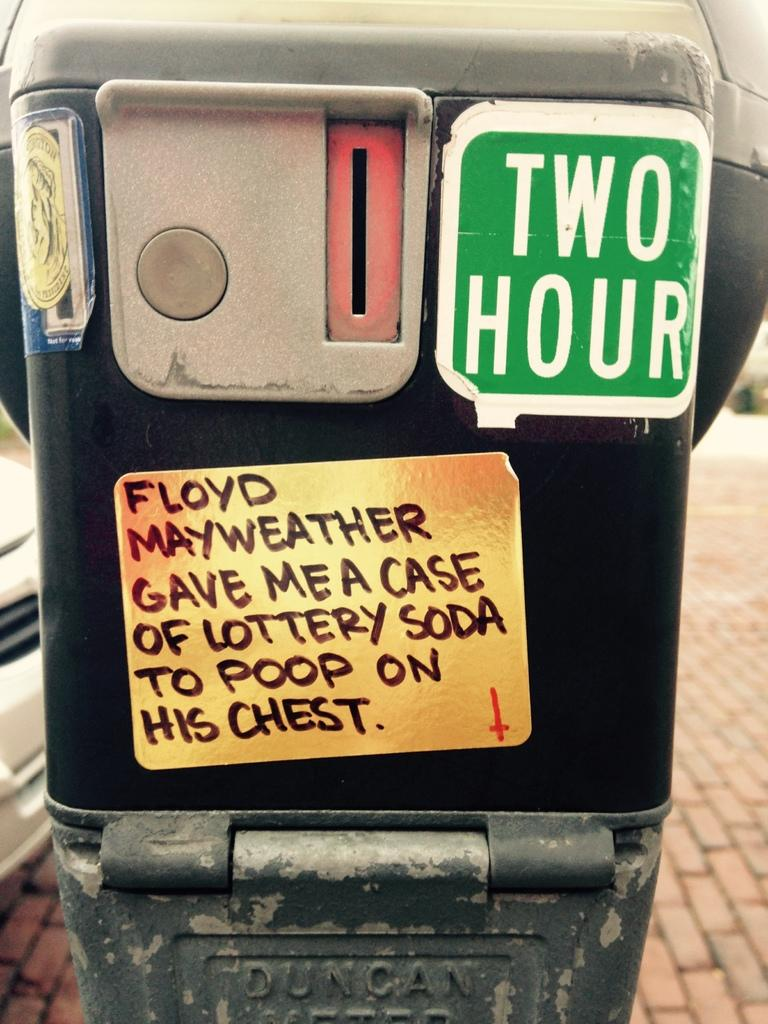<image>
Summarize the visual content of the image. Parking meter that tells people that the limit is two hours. 